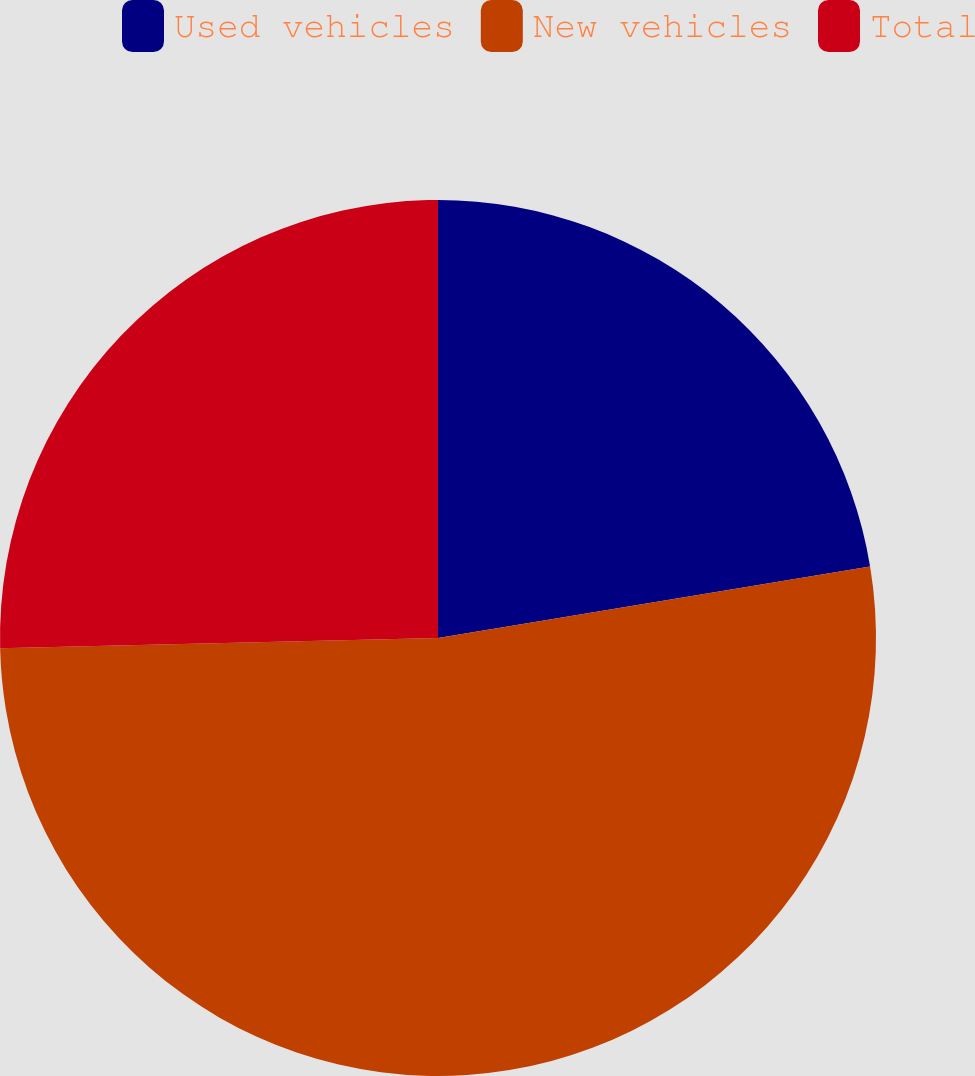Convert chart to OTSL. <chart><loc_0><loc_0><loc_500><loc_500><pie_chart><fcel>Used vehicles<fcel>New vehicles<fcel>Total<nl><fcel>22.39%<fcel>52.24%<fcel>25.37%<nl></chart> 